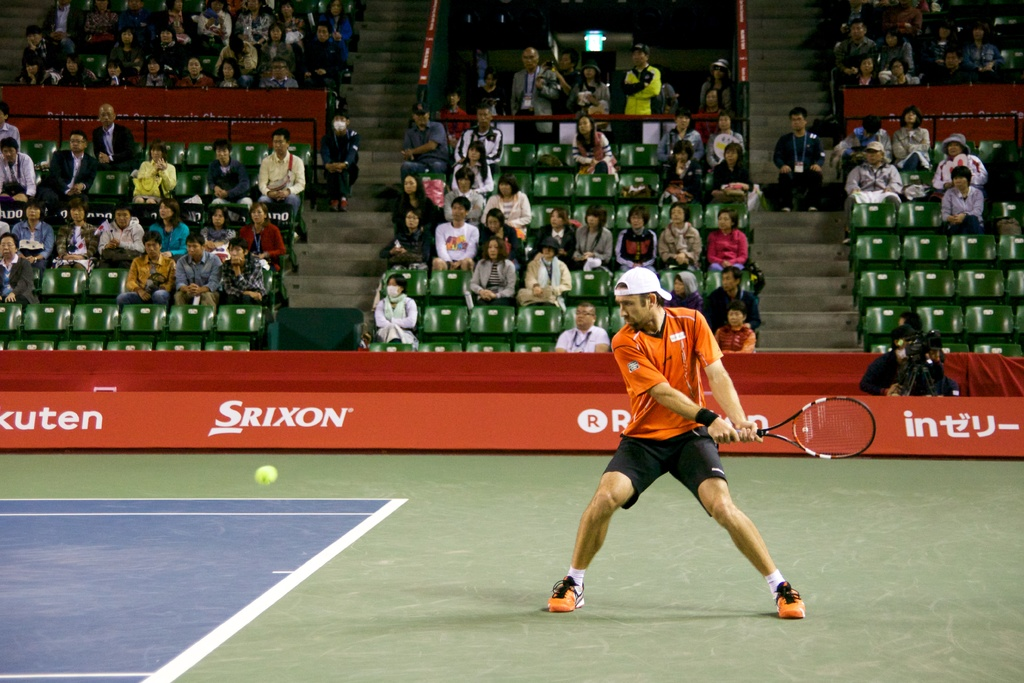What is the significance of the advertisement visible in the background of this tennis match? The presence of the Srixon advertisement suggests that the event is likely sponsored by the brand, which is known for its sports equipment. Sponsorships like this help fund the event and provide athletes with high-quality gear. 